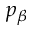Convert formula to latex. <formula><loc_0><loc_0><loc_500><loc_500>p _ { \beta }</formula> 